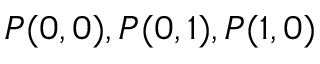<formula> <loc_0><loc_0><loc_500><loc_500>P ( 0 , 0 ) , P ( 0 , 1 ) , P ( 1 , 0 )</formula> 